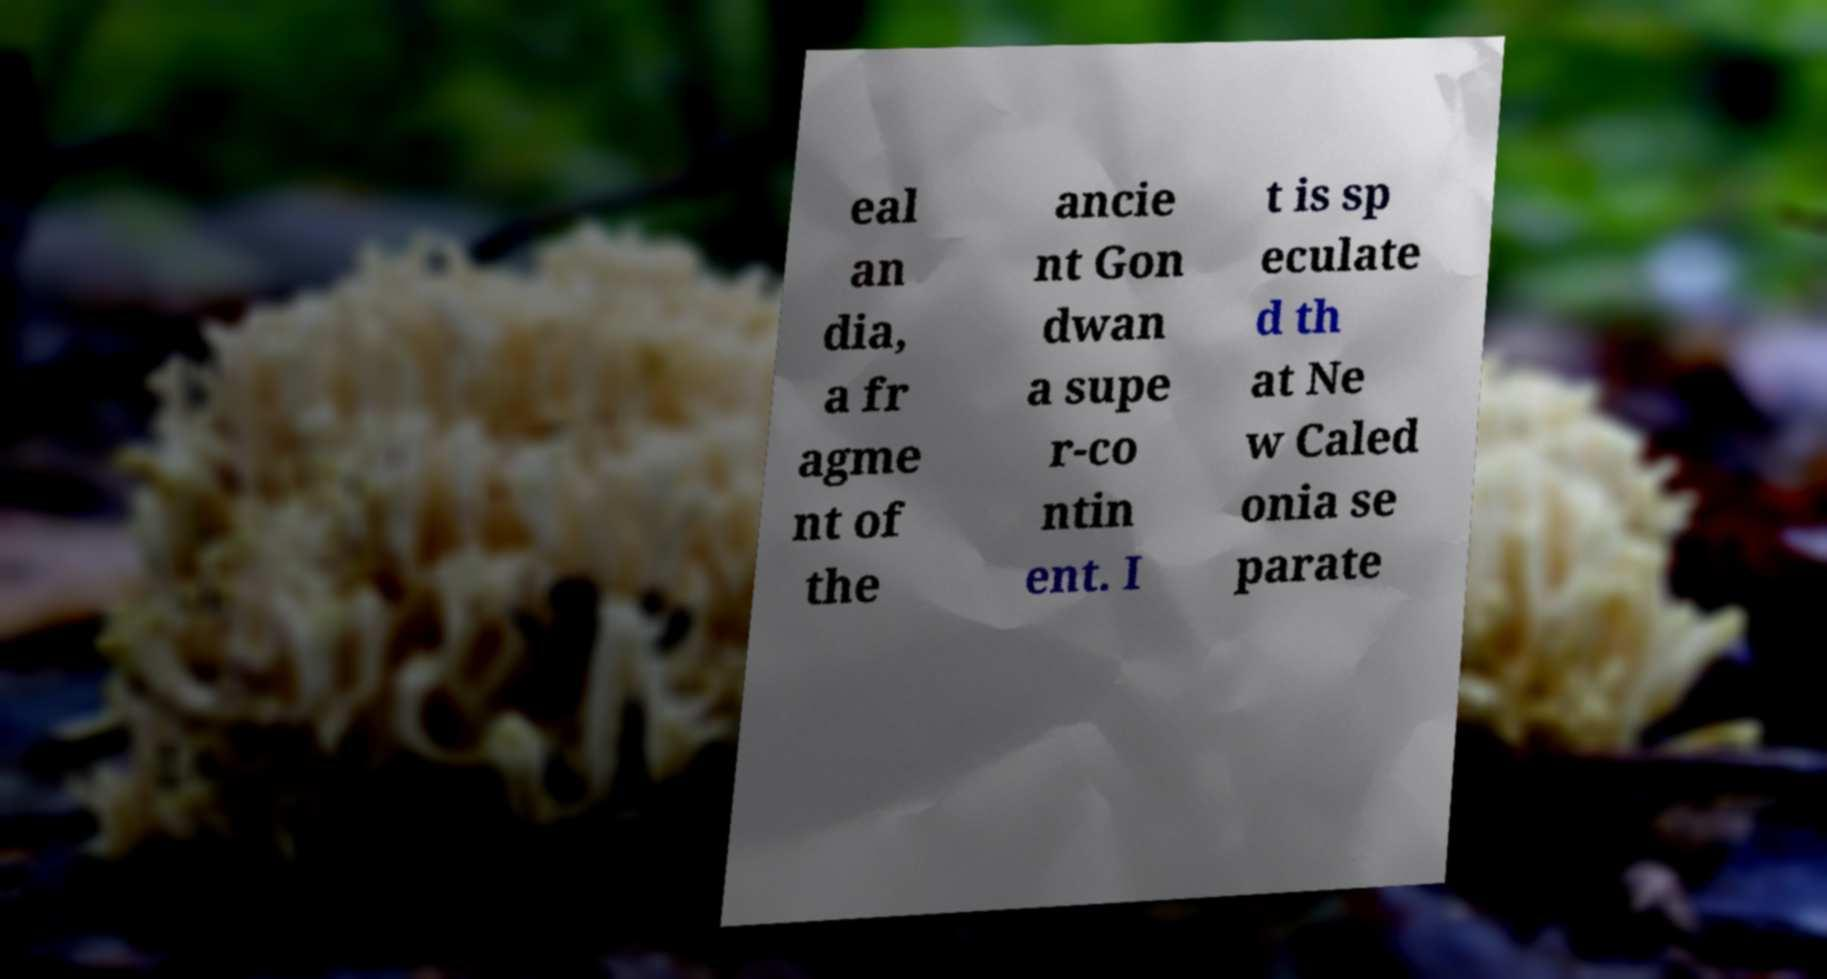I need the written content from this picture converted into text. Can you do that? eal an dia, a fr agme nt of the ancie nt Gon dwan a supe r-co ntin ent. I t is sp eculate d th at Ne w Caled onia se parate 